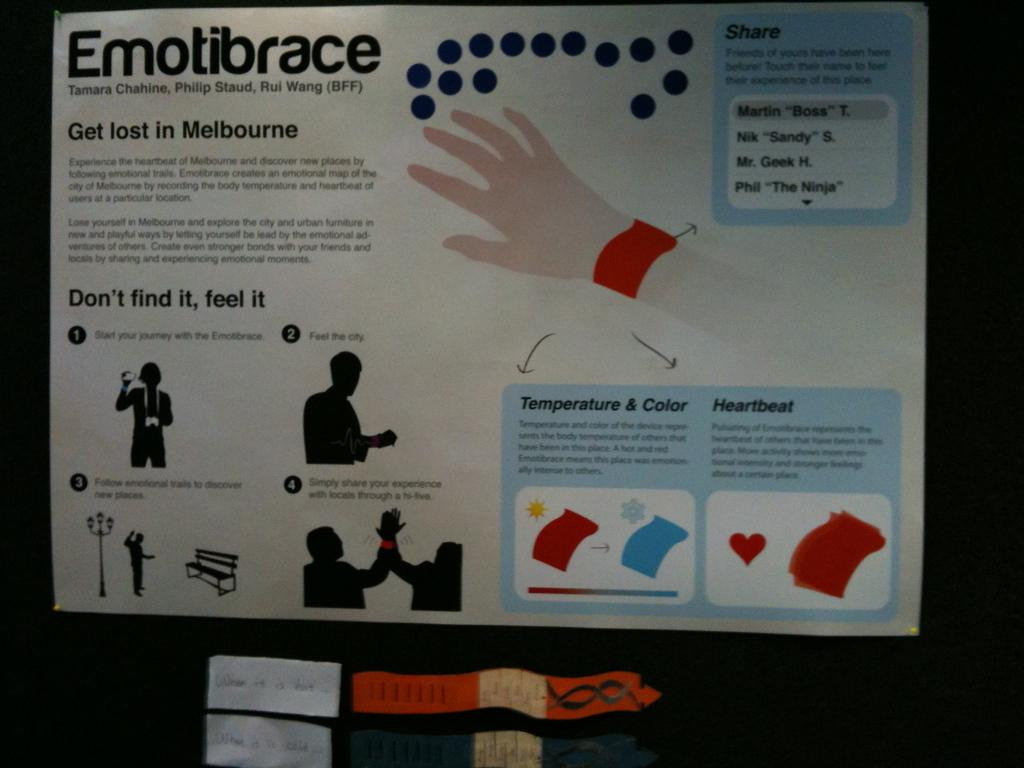Provide a one-sentence caption for the provided image. a poster with a lot of information is titled Emotibrace. 